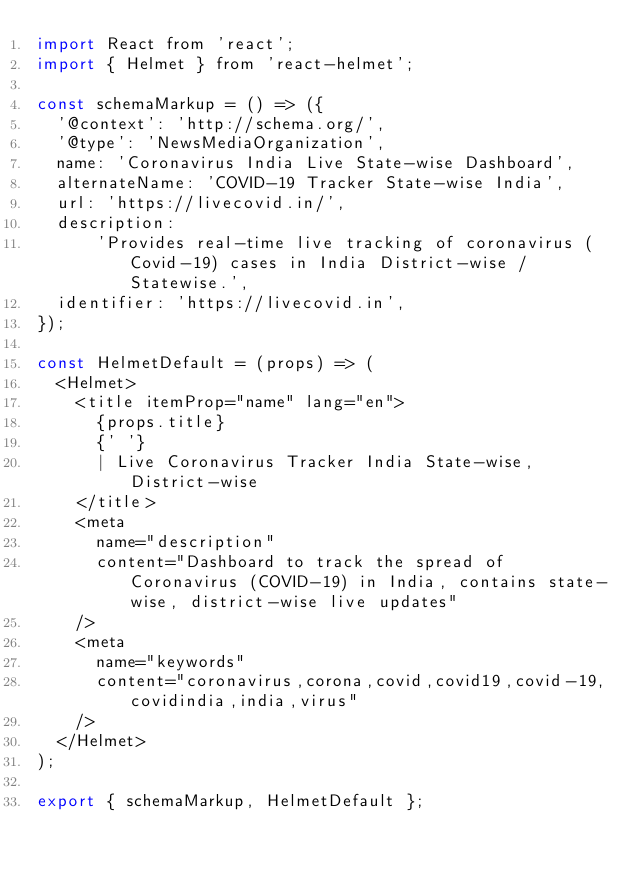<code> <loc_0><loc_0><loc_500><loc_500><_JavaScript_>import React from 'react';
import { Helmet } from 'react-helmet';

const schemaMarkup = () => ({
  '@context': 'http://schema.org/',
  '@type': 'NewsMediaOrganization',
  name: 'Coronavirus India Live State-wise Dashboard',
  alternateName: 'COVID-19 Tracker State-wise India',
  url: 'https://livecovid.in/',
  description:
      'Provides real-time live tracking of coronavirus (Covid-19) cases in India District-wise / Statewise.',
  identifier: 'https://livecovid.in',
});

const HelmetDefault = (props) => (
  <Helmet>
    <title itemProp="name" lang="en">
      {props.title}
      {' '}
      | Live Coronavirus Tracker India State-wise, District-wise
    </title>
    <meta
      name="description"
      content="Dashboard to track the spread of Coronavirus (COVID-19) in India, contains state-wise, district-wise live updates"
    />
    <meta
      name="keywords"
      content="coronavirus,corona,covid,covid19,covid-19,covidindia,india,virus"
    />
  </Helmet>
);

export { schemaMarkup, HelmetDefault };
</code> 